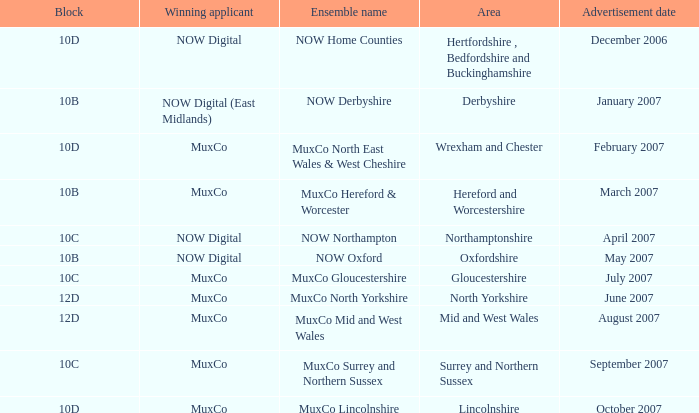Who is the Winning Applicant of Block 10B in Derbyshire Area? NOW Digital (East Midlands). 